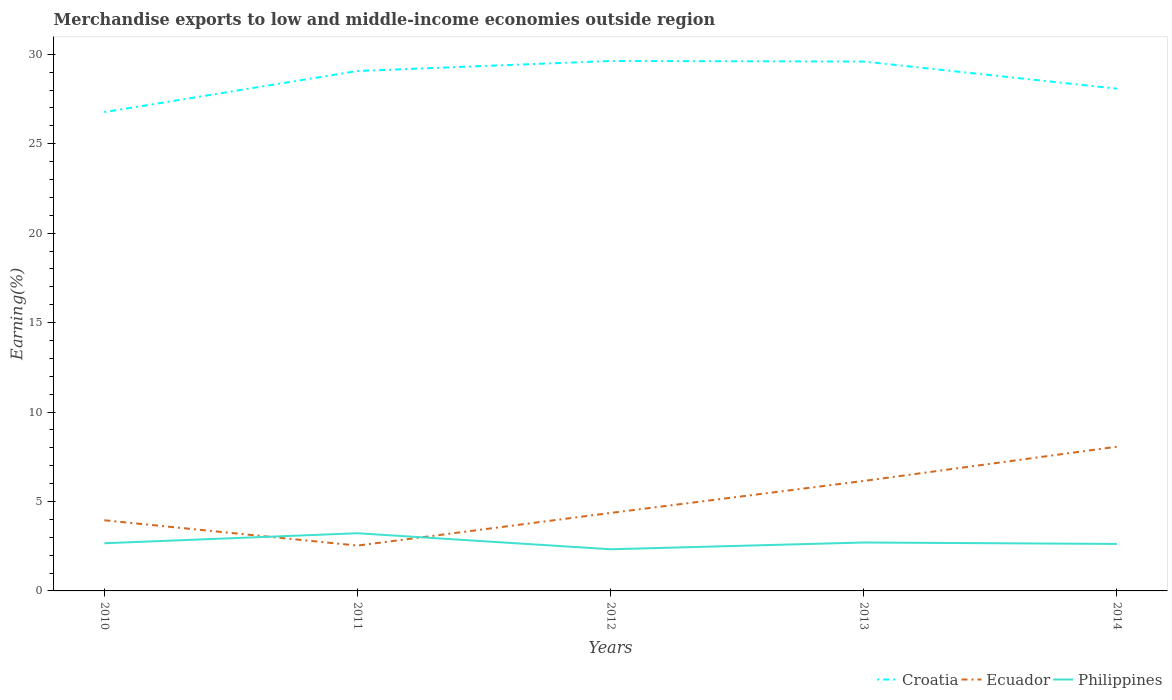Does the line corresponding to Ecuador intersect with the line corresponding to Philippines?
Offer a terse response. Yes. Is the number of lines equal to the number of legend labels?
Your answer should be compact. Yes. Across all years, what is the maximum percentage of amount earned from merchandise exports in Ecuador?
Your response must be concise. 2.53. In which year was the percentage of amount earned from merchandise exports in Philippines maximum?
Provide a short and direct response. 2012. What is the total percentage of amount earned from merchandise exports in Philippines in the graph?
Provide a short and direct response. -0.3. What is the difference between the highest and the second highest percentage of amount earned from merchandise exports in Philippines?
Offer a terse response. 0.9. What is the difference between the highest and the lowest percentage of amount earned from merchandise exports in Philippines?
Offer a very short reply. 1. What is the difference between two consecutive major ticks on the Y-axis?
Your answer should be very brief. 5. Does the graph contain grids?
Keep it short and to the point. No. Where does the legend appear in the graph?
Give a very brief answer. Bottom right. What is the title of the graph?
Your answer should be very brief. Merchandise exports to low and middle-income economies outside region. What is the label or title of the Y-axis?
Keep it short and to the point. Earning(%). What is the Earning(%) in Croatia in 2010?
Make the answer very short. 26.77. What is the Earning(%) in Ecuador in 2010?
Ensure brevity in your answer.  3.95. What is the Earning(%) in Philippines in 2010?
Offer a terse response. 2.67. What is the Earning(%) of Croatia in 2011?
Your answer should be compact. 29.07. What is the Earning(%) in Ecuador in 2011?
Your response must be concise. 2.53. What is the Earning(%) of Philippines in 2011?
Your answer should be very brief. 3.22. What is the Earning(%) in Croatia in 2012?
Provide a succinct answer. 29.63. What is the Earning(%) in Ecuador in 2012?
Make the answer very short. 4.36. What is the Earning(%) in Philippines in 2012?
Your answer should be very brief. 2.33. What is the Earning(%) of Croatia in 2013?
Make the answer very short. 29.6. What is the Earning(%) in Ecuador in 2013?
Keep it short and to the point. 6.15. What is the Earning(%) in Philippines in 2013?
Your answer should be very brief. 2.71. What is the Earning(%) of Croatia in 2014?
Provide a succinct answer. 28.08. What is the Earning(%) in Ecuador in 2014?
Offer a terse response. 8.06. What is the Earning(%) in Philippines in 2014?
Your response must be concise. 2.63. Across all years, what is the maximum Earning(%) of Croatia?
Your answer should be compact. 29.63. Across all years, what is the maximum Earning(%) in Ecuador?
Make the answer very short. 8.06. Across all years, what is the maximum Earning(%) in Philippines?
Give a very brief answer. 3.22. Across all years, what is the minimum Earning(%) of Croatia?
Your answer should be compact. 26.77. Across all years, what is the minimum Earning(%) in Ecuador?
Your response must be concise. 2.53. Across all years, what is the minimum Earning(%) in Philippines?
Provide a short and direct response. 2.33. What is the total Earning(%) of Croatia in the graph?
Your answer should be very brief. 143.14. What is the total Earning(%) in Ecuador in the graph?
Your answer should be very brief. 25.06. What is the total Earning(%) in Philippines in the graph?
Your answer should be very brief. 13.55. What is the difference between the Earning(%) in Croatia in 2010 and that in 2011?
Make the answer very short. -2.3. What is the difference between the Earning(%) of Ecuador in 2010 and that in 2011?
Keep it short and to the point. 1.42. What is the difference between the Earning(%) in Philippines in 2010 and that in 2011?
Give a very brief answer. -0.56. What is the difference between the Earning(%) in Croatia in 2010 and that in 2012?
Offer a terse response. -2.86. What is the difference between the Earning(%) in Ecuador in 2010 and that in 2012?
Provide a short and direct response. -0.41. What is the difference between the Earning(%) in Philippines in 2010 and that in 2012?
Offer a very short reply. 0.34. What is the difference between the Earning(%) in Croatia in 2010 and that in 2013?
Keep it short and to the point. -2.83. What is the difference between the Earning(%) in Ecuador in 2010 and that in 2013?
Provide a short and direct response. -2.2. What is the difference between the Earning(%) in Philippines in 2010 and that in 2013?
Your answer should be very brief. -0.04. What is the difference between the Earning(%) of Croatia in 2010 and that in 2014?
Make the answer very short. -1.31. What is the difference between the Earning(%) in Ecuador in 2010 and that in 2014?
Offer a terse response. -4.11. What is the difference between the Earning(%) in Philippines in 2010 and that in 2014?
Provide a short and direct response. 0.04. What is the difference between the Earning(%) in Croatia in 2011 and that in 2012?
Keep it short and to the point. -0.56. What is the difference between the Earning(%) in Ecuador in 2011 and that in 2012?
Offer a very short reply. -1.83. What is the difference between the Earning(%) in Philippines in 2011 and that in 2012?
Provide a short and direct response. 0.9. What is the difference between the Earning(%) of Croatia in 2011 and that in 2013?
Your answer should be very brief. -0.53. What is the difference between the Earning(%) in Ecuador in 2011 and that in 2013?
Your answer should be compact. -3.61. What is the difference between the Earning(%) of Philippines in 2011 and that in 2013?
Ensure brevity in your answer.  0.52. What is the difference between the Earning(%) of Croatia in 2011 and that in 2014?
Offer a terse response. 0.99. What is the difference between the Earning(%) of Ecuador in 2011 and that in 2014?
Keep it short and to the point. -5.53. What is the difference between the Earning(%) of Philippines in 2011 and that in 2014?
Your response must be concise. 0.6. What is the difference between the Earning(%) of Croatia in 2012 and that in 2013?
Offer a very short reply. 0.03. What is the difference between the Earning(%) in Ecuador in 2012 and that in 2013?
Provide a short and direct response. -1.79. What is the difference between the Earning(%) of Philippines in 2012 and that in 2013?
Offer a very short reply. -0.38. What is the difference between the Earning(%) of Croatia in 2012 and that in 2014?
Provide a succinct answer. 1.55. What is the difference between the Earning(%) of Ecuador in 2012 and that in 2014?
Your answer should be very brief. -3.7. What is the difference between the Earning(%) in Philippines in 2012 and that in 2014?
Ensure brevity in your answer.  -0.3. What is the difference between the Earning(%) of Croatia in 2013 and that in 2014?
Keep it short and to the point. 1.52. What is the difference between the Earning(%) in Ecuador in 2013 and that in 2014?
Keep it short and to the point. -1.91. What is the difference between the Earning(%) of Philippines in 2013 and that in 2014?
Provide a short and direct response. 0.08. What is the difference between the Earning(%) in Croatia in 2010 and the Earning(%) in Ecuador in 2011?
Your answer should be compact. 24.23. What is the difference between the Earning(%) of Croatia in 2010 and the Earning(%) of Philippines in 2011?
Ensure brevity in your answer.  23.54. What is the difference between the Earning(%) in Ecuador in 2010 and the Earning(%) in Philippines in 2011?
Give a very brief answer. 0.73. What is the difference between the Earning(%) in Croatia in 2010 and the Earning(%) in Ecuador in 2012?
Your answer should be very brief. 22.41. What is the difference between the Earning(%) of Croatia in 2010 and the Earning(%) of Philippines in 2012?
Your answer should be very brief. 24.44. What is the difference between the Earning(%) of Ecuador in 2010 and the Earning(%) of Philippines in 2012?
Offer a terse response. 1.62. What is the difference between the Earning(%) of Croatia in 2010 and the Earning(%) of Ecuador in 2013?
Keep it short and to the point. 20.62. What is the difference between the Earning(%) of Croatia in 2010 and the Earning(%) of Philippines in 2013?
Make the answer very short. 24.06. What is the difference between the Earning(%) in Ecuador in 2010 and the Earning(%) in Philippines in 2013?
Offer a terse response. 1.24. What is the difference between the Earning(%) of Croatia in 2010 and the Earning(%) of Ecuador in 2014?
Provide a succinct answer. 18.71. What is the difference between the Earning(%) in Croatia in 2010 and the Earning(%) in Philippines in 2014?
Make the answer very short. 24.14. What is the difference between the Earning(%) in Ecuador in 2010 and the Earning(%) in Philippines in 2014?
Make the answer very short. 1.32. What is the difference between the Earning(%) of Croatia in 2011 and the Earning(%) of Ecuador in 2012?
Make the answer very short. 24.71. What is the difference between the Earning(%) of Croatia in 2011 and the Earning(%) of Philippines in 2012?
Ensure brevity in your answer.  26.74. What is the difference between the Earning(%) of Ecuador in 2011 and the Earning(%) of Philippines in 2012?
Ensure brevity in your answer.  0.21. What is the difference between the Earning(%) in Croatia in 2011 and the Earning(%) in Ecuador in 2013?
Offer a terse response. 22.92. What is the difference between the Earning(%) of Croatia in 2011 and the Earning(%) of Philippines in 2013?
Provide a short and direct response. 26.36. What is the difference between the Earning(%) of Ecuador in 2011 and the Earning(%) of Philippines in 2013?
Your response must be concise. -0.17. What is the difference between the Earning(%) of Croatia in 2011 and the Earning(%) of Ecuador in 2014?
Offer a very short reply. 21. What is the difference between the Earning(%) in Croatia in 2011 and the Earning(%) in Philippines in 2014?
Give a very brief answer. 26.44. What is the difference between the Earning(%) of Ecuador in 2011 and the Earning(%) of Philippines in 2014?
Offer a very short reply. -0.09. What is the difference between the Earning(%) of Croatia in 2012 and the Earning(%) of Ecuador in 2013?
Make the answer very short. 23.48. What is the difference between the Earning(%) of Croatia in 2012 and the Earning(%) of Philippines in 2013?
Provide a short and direct response. 26.92. What is the difference between the Earning(%) in Ecuador in 2012 and the Earning(%) in Philippines in 2013?
Make the answer very short. 1.65. What is the difference between the Earning(%) in Croatia in 2012 and the Earning(%) in Ecuador in 2014?
Your answer should be very brief. 21.56. What is the difference between the Earning(%) in Croatia in 2012 and the Earning(%) in Philippines in 2014?
Provide a succinct answer. 27. What is the difference between the Earning(%) of Ecuador in 2012 and the Earning(%) of Philippines in 2014?
Provide a succinct answer. 1.73. What is the difference between the Earning(%) in Croatia in 2013 and the Earning(%) in Ecuador in 2014?
Provide a succinct answer. 21.53. What is the difference between the Earning(%) in Croatia in 2013 and the Earning(%) in Philippines in 2014?
Offer a terse response. 26.97. What is the difference between the Earning(%) in Ecuador in 2013 and the Earning(%) in Philippines in 2014?
Provide a short and direct response. 3.52. What is the average Earning(%) in Croatia per year?
Ensure brevity in your answer.  28.63. What is the average Earning(%) of Ecuador per year?
Offer a terse response. 5.01. What is the average Earning(%) in Philippines per year?
Your answer should be compact. 2.71. In the year 2010, what is the difference between the Earning(%) of Croatia and Earning(%) of Ecuador?
Ensure brevity in your answer.  22.82. In the year 2010, what is the difference between the Earning(%) in Croatia and Earning(%) in Philippines?
Offer a very short reply. 24.1. In the year 2010, what is the difference between the Earning(%) in Ecuador and Earning(%) in Philippines?
Ensure brevity in your answer.  1.28. In the year 2011, what is the difference between the Earning(%) in Croatia and Earning(%) in Ecuador?
Offer a terse response. 26.53. In the year 2011, what is the difference between the Earning(%) in Croatia and Earning(%) in Philippines?
Provide a short and direct response. 25.84. In the year 2011, what is the difference between the Earning(%) of Ecuador and Earning(%) of Philippines?
Your answer should be very brief. -0.69. In the year 2012, what is the difference between the Earning(%) in Croatia and Earning(%) in Ecuador?
Offer a very short reply. 25.27. In the year 2012, what is the difference between the Earning(%) in Croatia and Earning(%) in Philippines?
Ensure brevity in your answer.  27.3. In the year 2012, what is the difference between the Earning(%) in Ecuador and Earning(%) in Philippines?
Your answer should be very brief. 2.03. In the year 2013, what is the difference between the Earning(%) of Croatia and Earning(%) of Ecuador?
Provide a succinct answer. 23.45. In the year 2013, what is the difference between the Earning(%) of Croatia and Earning(%) of Philippines?
Offer a very short reply. 26.89. In the year 2013, what is the difference between the Earning(%) of Ecuador and Earning(%) of Philippines?
Your response must be concise. 3.44. In the year 2014, what is the difference between the Earning(%) in Croatia and Earning(%) in Ecuador?
Your answer should be very brief. 20.02. In the year 2014, what is the difference between the Earning(%) of Croatia and Earning(%) of Philippines?
Provide a succinct answer. 25.45. In the year 2014, what is the difference between the Earning(%) of Ecuador and Earning(%) of Philippines?
Provide a short and direct response. 5.44. What is the ratio of the Earning(%) of Croatia in 2010 to that in 2011?
Your answer should be compact. 0.92. What is the ratio of the Earning(%) in Ecuador in 2010 to that in 2011?
Provide a succinct answer. 1.56. What is the ratio of the Earning(%) of Philippines in 2010 to that in 2011?
Give a very brief answer. 0.83. What is the ratio of the Earning(%) in Croatia in 2010 to that in 2012?
Ensure brevity in your answer.  0.9. What is the ratio of the Earning(%) in Ecuador in 2010 to that in 2012?
Your answer should be very brief. 0.91. What is the ratio of the Earning(%) in Philippines in 2010 to that in 2012?
Your response must be concise. 1.14. What is the ratio of the Earning(%) in Croatia in 2010 to that in 2013?
Your answer should be compact. 0.9. What is the ratio of the Earning(%) of Ecuador in 2010 to that in 2013?
Ensure brevity in your answer.  0.64. What is the ratio of the Earning(%) in Philippines in 2010 to that in 2013?
Your answer should be compact. 0.98. What is the ratio of the Earning(%) of Croatia in 2010 to that in 2014?
Make the answer very short. 0.95. What is the ratio of the Earning(%) in Ecuador in 2010 to that in 2014?
Your response must be concise. 0.49. What is the ratio of the Earning(%) of Philippines in 2010 to that in 2014?
Ensure brevity in your answer.  1.01. What is the ratio of the Earning(%) in Croatia in 2011 to that in 2012?
Provide a short and direct response. 0.98. What is the ratio of the Earning(%) in Ecuador in 2011 to that in 2012?
Offer a terse response. 0.58. What is the ratio of the Earning(%) in Philippines in 2011 to that in 2012?
Give a very brief answer. 1.38. What is the ratio of the Earning(%) of Croatia in 2011 to that in 2013?
Keep it short and to the point. 0.98. What is the ratio of the Earning(%) of Ecuador in 2011 to that in 2013?
Offer a very short reply. 0.41. What is the ratio of the Earning(%) in Philippines in 2011 to that in 2013?
Provide a short and direct response. 1.19. What is the ratio of the Earning(%) in Croatia in 2011 to that in 2014?
Make the answer very short. 1.04. What is the ratio of the Earning(%) in Ecuador in 2011 to that in 2014?
Make the answer very short. 0.31. What is the ratio of the Earning(%) in Philippines in 2011 to that in 2014?
Offer a terse response. 1.23. What is the ratio of the Earning(%) of Ecuador in 2012 to that in 2013?
Offer a terse response. 0.71. What is the ratio of the Earning(%) of Philippines in 2012 to that in 2013?
Provide a succinct answer. 0.86. What is the ratio of the Earning(%) of Croatia in 2012 to that in 2014?
Offer a terse response. 1.06. What is the ratio of the Earning(%) of Ecuador in 2012 to that in 2014?
Provide a succinct answer. 0.54. What is the ratio of the Earning(%) of Philippines in 2012 to that in 2014?
Your answer should be compact. 0.89. What is the ratio of the Earning(%) of Croatia in 2013 to that in 2014?
Offer a terse response. 1.05. What is the ratio of the Earning(%) in Ecuador in 2013 to that in 2014?
Provide a short and direct response. 0.76. What is the ratio of the Earning(%) of Philippines in 2013 to that in 2014?
Offer a very short reply. 1.03. What is the difference between the highest and the second highest Earning(%) in Croatia?
Keep it short and to the point. 0.03. What is the difference between the highest and the second highest Earning(%) of Ecuador?
Provide a succinct answer. 1.91. What is the difference between the highest and the second highest Earning(%) in Philippines?
Your response must be concise. 0.52. What is the difference between the highest and the lowest Earning(%) of Croatia?
Your answer should be compact. 2.86. What is the difference between the highest and the lowest Earning(%) in Ecuador?
Provide a short and direct response. 5.53. What is the difference between the highest and the lowest Earning(%) of Philippines?
Your answer should be very brief. 0.9. 